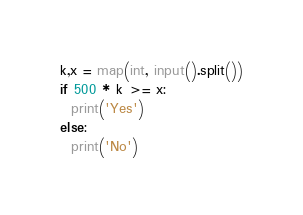Convert code to text. <code><loc_0><loc_0><loc_500><loc_500><_Python_>k,x = map(int, input().split())
if 500 * k >= x:
  print('Yes')
else:
  print('No')</code> 